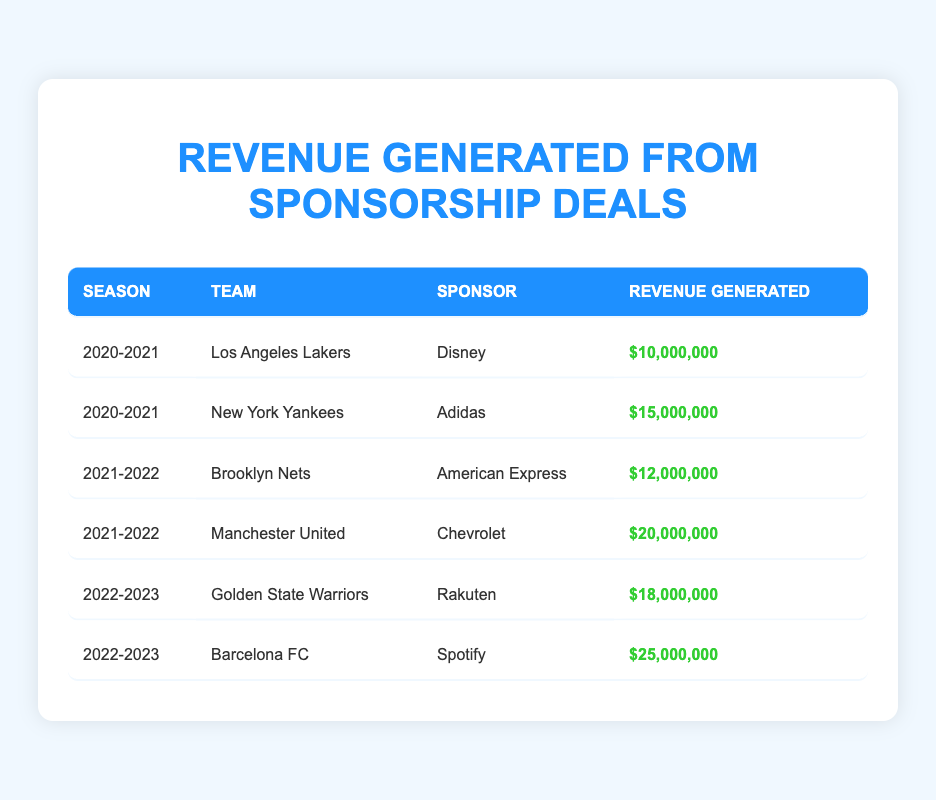What team had the highest revenue from sponsorship deals in the 2022-2023 season? The table shows that Barcelona FC had revenue of 25,000,000, which is the highest in that season.
Answer: Barcelona FC What was the total revenue generated by Los Angeles Lakers and New York Yankees in the 2020-2021 season? The Lakers generated 10,000,000 and the Yankees generated 15,000,000. Adding these together gives 10,000,000 + 15,000,000 = 25,000,000.
Answer: 25,000,000 Did the Brooklyn Nets generate more revenue than the Los Angeles Lakers? The Brooklyn Nets generated 12,000,000 while the Los Angeles Lakers generated 10,000,000. Since 12,000,000 is greater than 10,000,000, the statement is true.
Answer: Yes What season generated the least total revenue across all sponsorship deals listed? To find this, I will sum the revenues for each season: 2020-2021 (10,000,000 + 15,000,000 = 25,000,000), 2021-2022 (12,000,000 + 20,000,000 = 32,000,000), and 2022-2023 (18,000,000 + 25,000,000 = 43,000,000). The season with the least revenue is 2020-2021 with 25,000,000.
Answer: 2020-2021 What is the average revenue generated by Manchester United and Golden State Warriors? Manchester United generated 20,000,000 and Golden State Warriors generated 18,000,000. To find the average, sum these values (20,000,000 + 18,000,000 = 38,000,000) and divide by 2, giving 38,000,000 / 2 = 19,000,000.
Answer: 19,000,000 